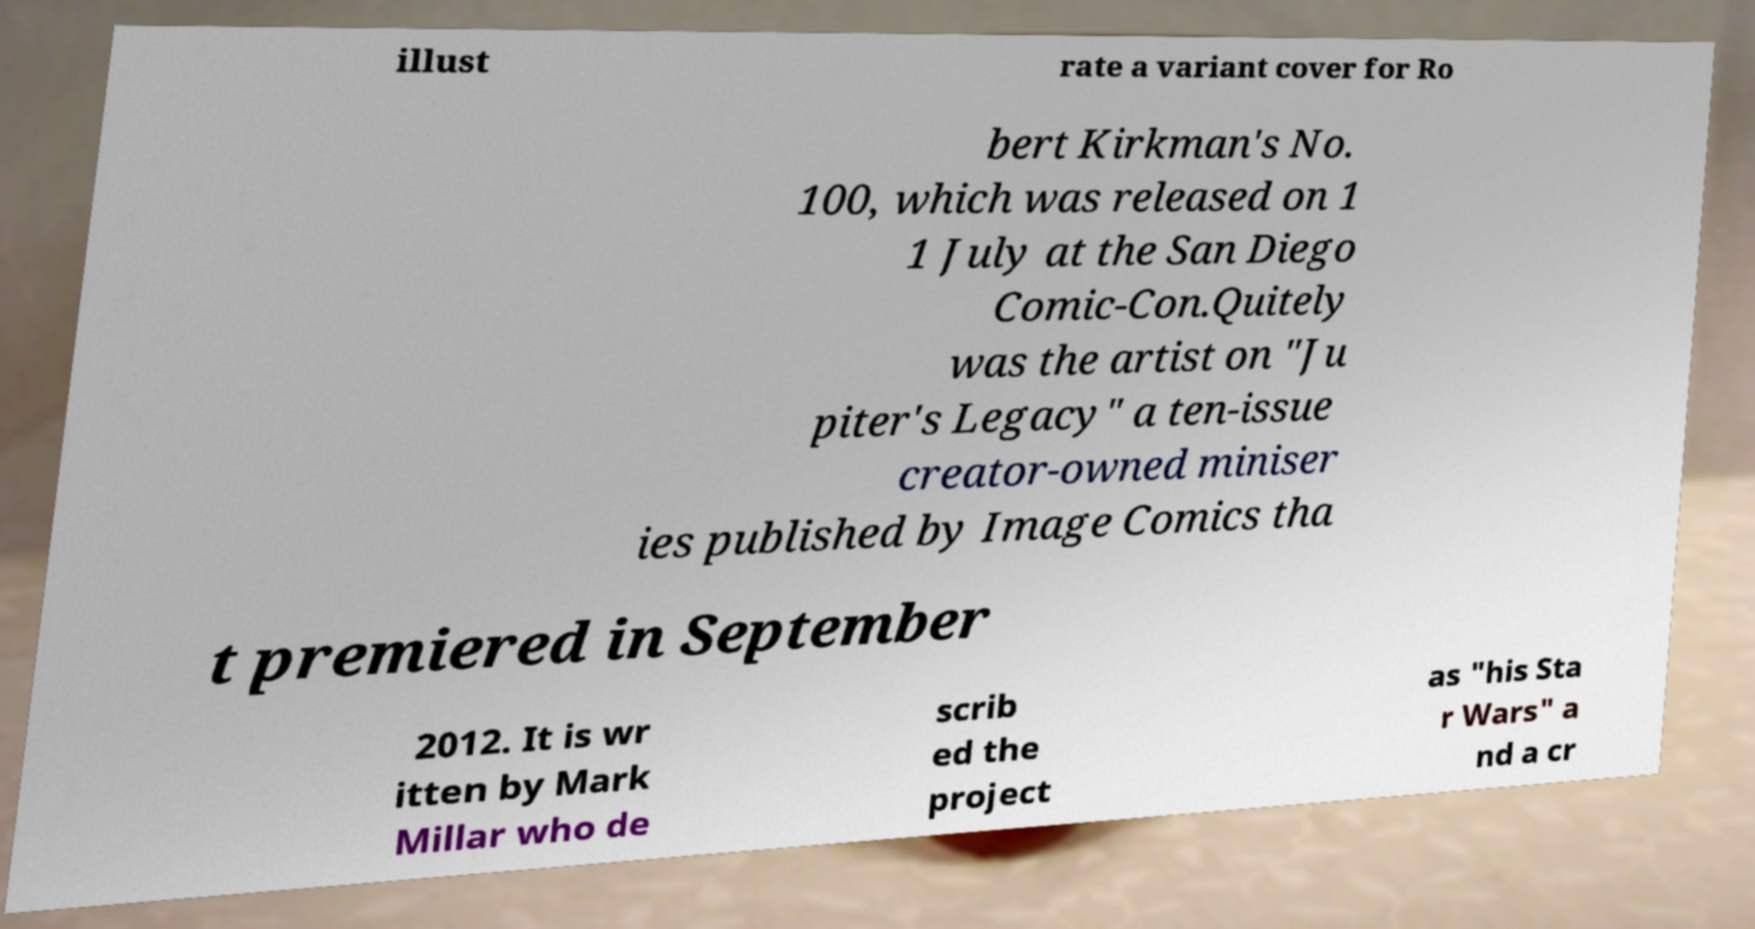There's text embedded in this image that I need extracted. Can you transcribe it verbatim? illust rate a variant cover for Ro bert Kirkman's No. 100, which was released on 1 1 July at the San Diego Comic-Con.Quitely was the artist on "Ju piter's Legacy" a ten-issue creator-owned miniser ies published by Image Comics tha t premiered in September 2012. It is wr itten by Mark Millar who de scrib ed the project as "his Sta r Wars" a nd a cr 